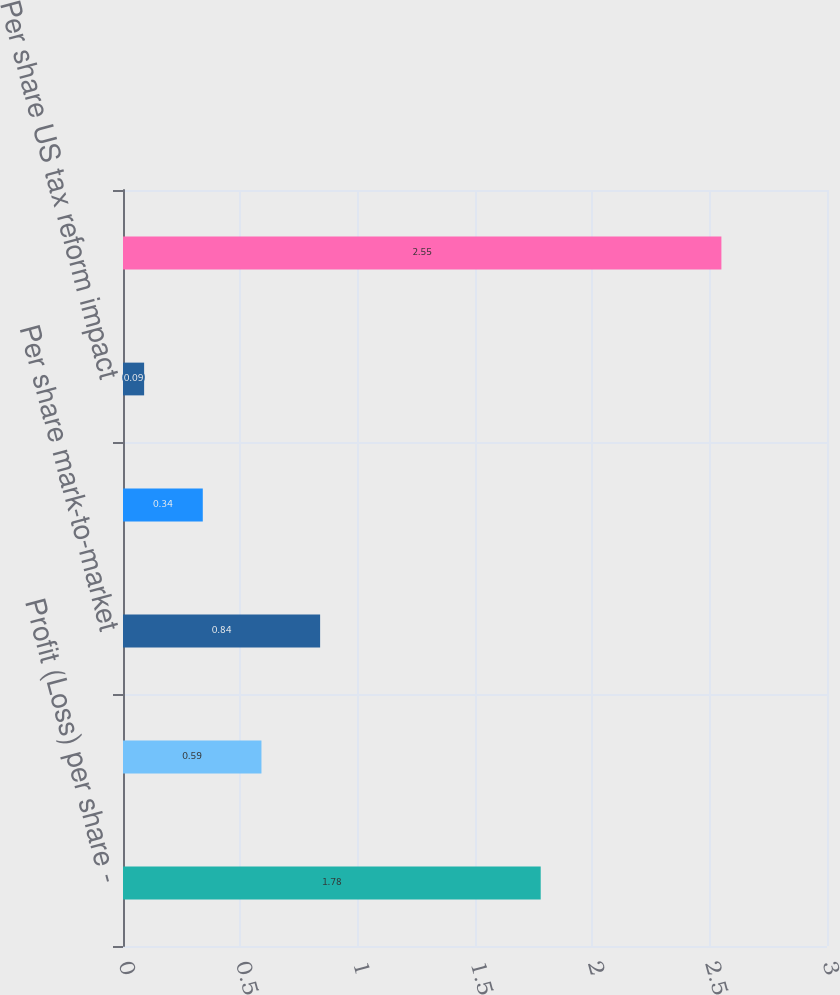<chart> <loc_0><loc_0><loc_500><loc_500><bar_chart><fcel>Profit (Loss) per share -<fcel>Per share restructuring costs<fcel>Per share mark-to-market<fcel>Per share deferred tax<fcel>Per share US tax reform impact<fcel>Adjusted profit per share<nl><fcel>1.78<fcel>0.59<fcel>0.84<fcel>0.34<fcel>0.09<fcel>2.55<nl></chart> 